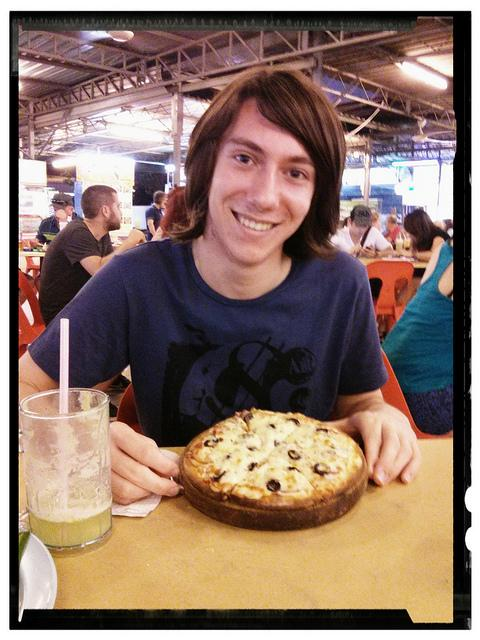What type of crust is this called? Please explain your reasoning. thick. You can tell by its thickness what type of crust it is. 